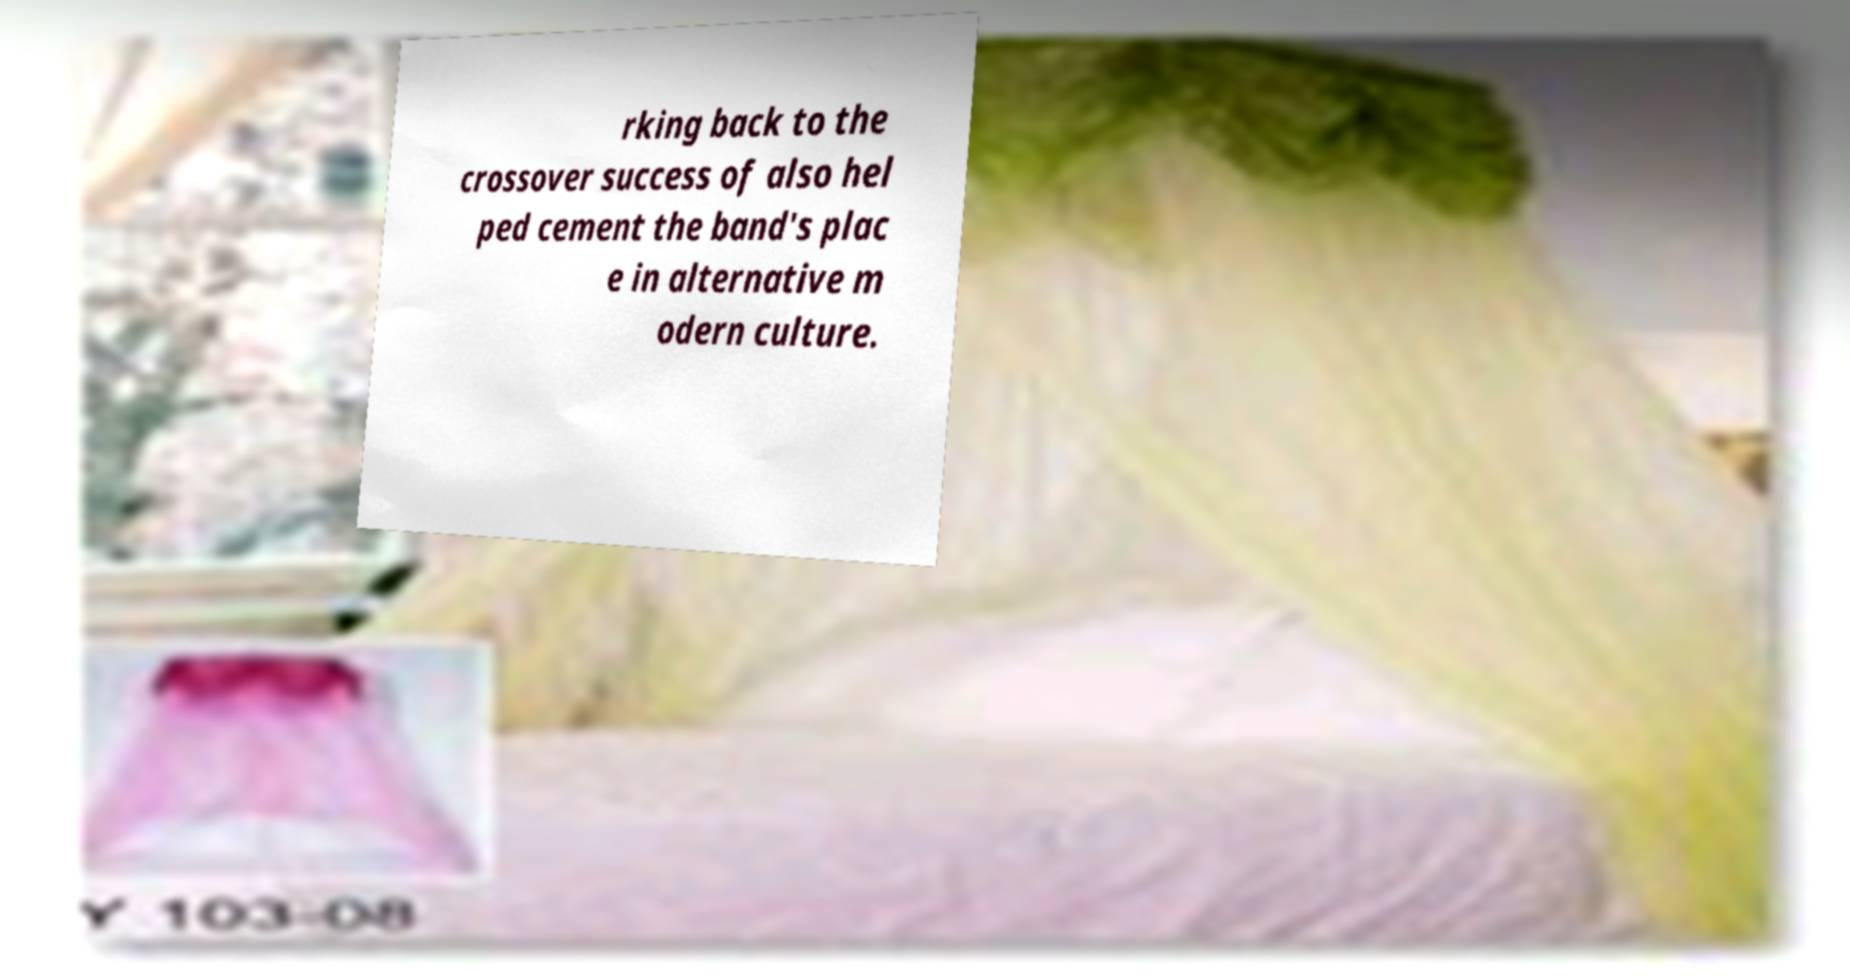Can you read and provide the text displayed in the image?This photo seems to have some interesting text. Can you extract and type it out for me? rking back to the crossover success of also hel ped cement the band's plac e in alternative m odern culture. 